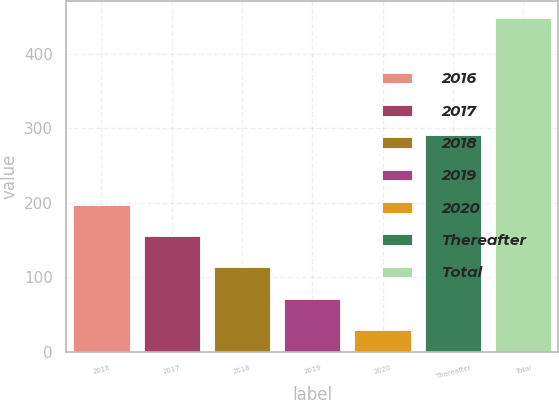<chart> <loc_0><loc_0><loc_500><loc_500><bar_chart><fcel>2016<fcel>2017<fcel>2018<fcel>2019<fcel>2020<fcel>Thereafter<fcel>Total<nl><fcel>196.8<fcel>154.9<fcel>113<fcel>71.1<fcel>29.2<fcel>291.6<fcel>448.2<nl></chart> 